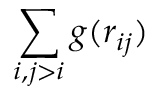Convert formula to latex. <formula><loc_0><loc_0><loc_500><loc_500>\sum _ { i , j > i } g ( r _ { i j } )</formula> 